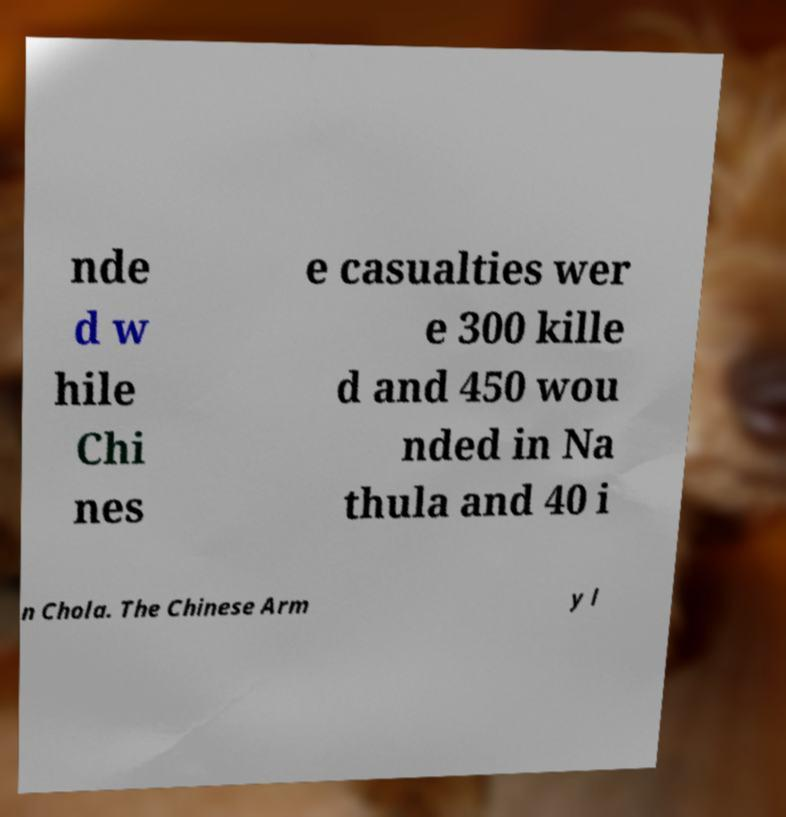Please identify and transcribe the text found in this image. nde d w hile Chi nes e casualties wer e 300 kille d and 450 wou nded in Na thula and 40 i n Chola. The Chinese Arm y l 